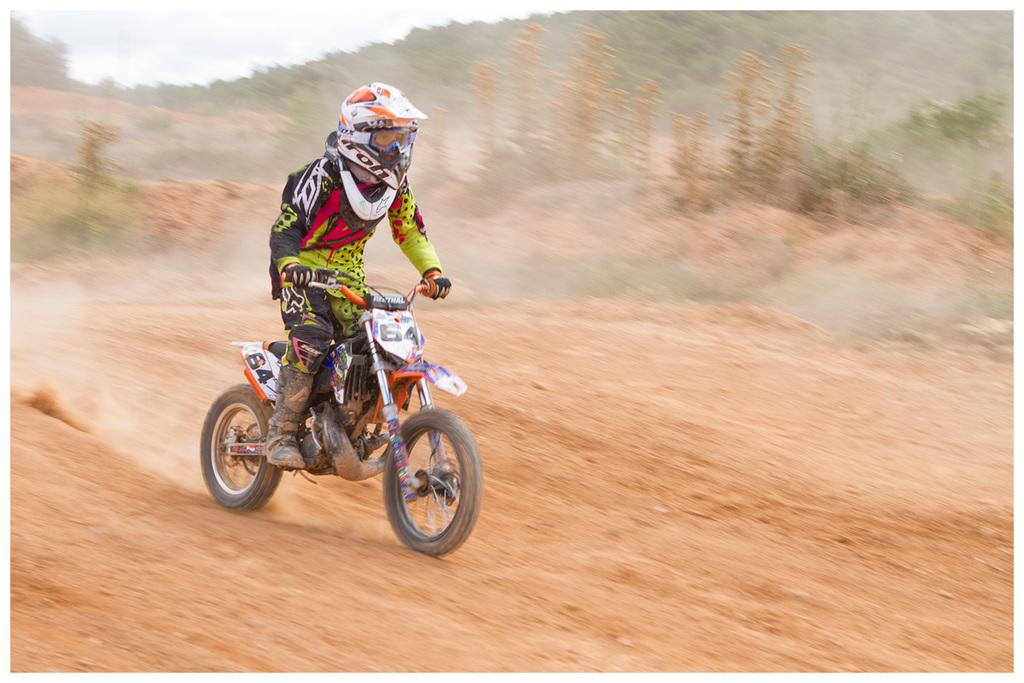What is the main subject of the image? There is a person in the image. What is the person wearing? The person is wearing a jacket and a helmet on their head. What activity is the person engaged in? The person is riding a bike. What is the position of the bike in the image? The bike is on the ground. What can be seen in the background of the image? There are plants and a hill in the background of the image. What decision is the person making while riding the bike in the image? There is no indication in the image that the person is making a decision while riding the bike. 